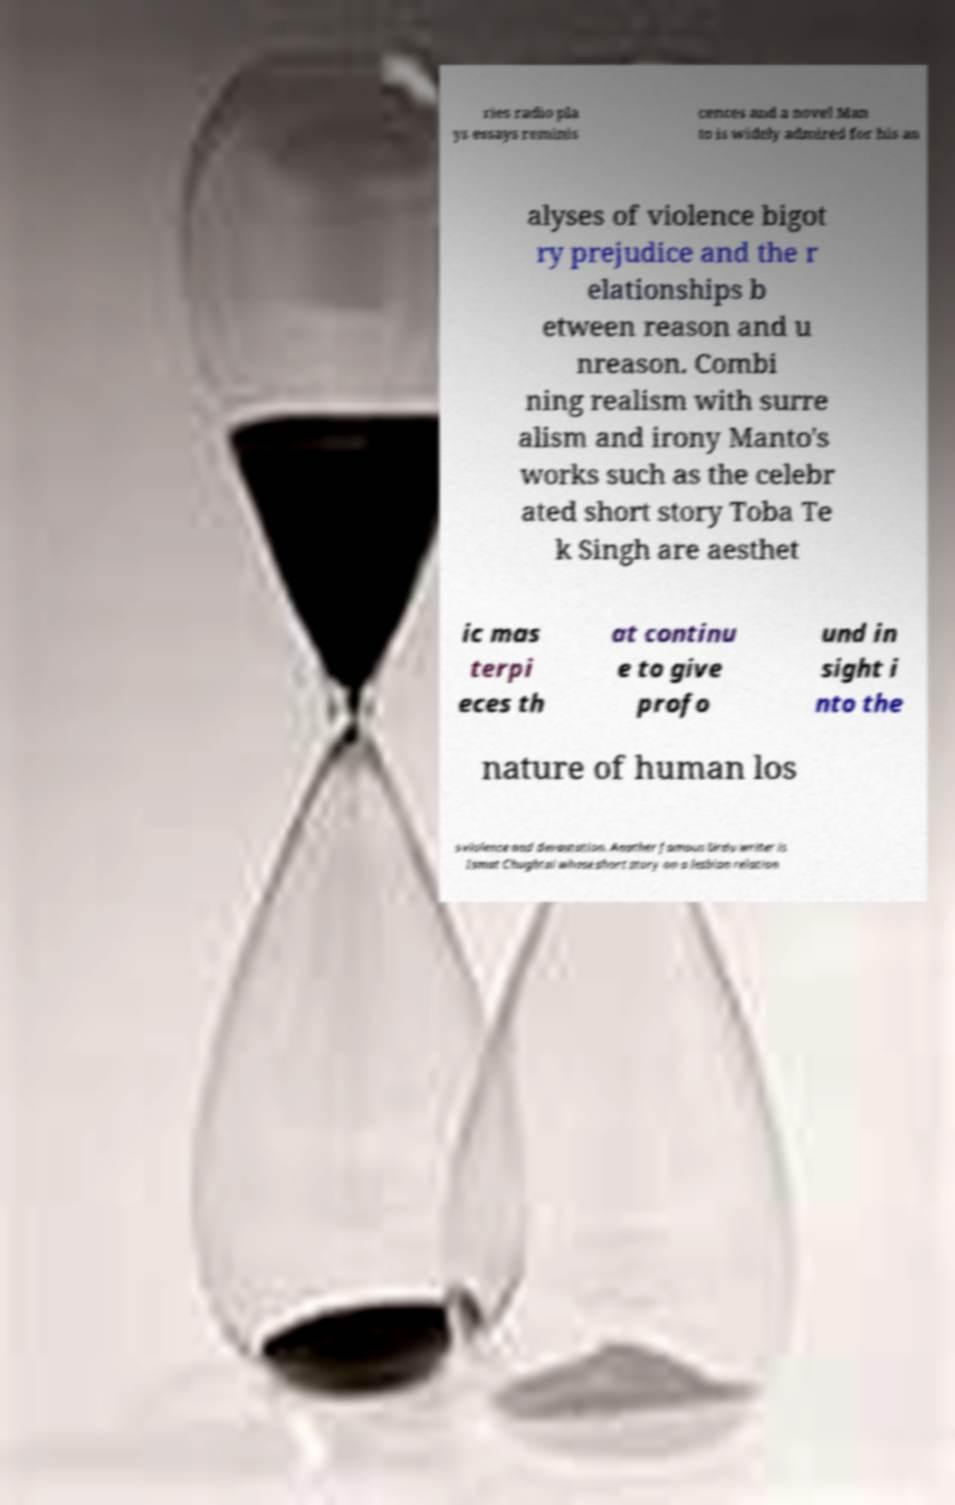Could you assist in decoding the text presented in this image and type it out clearly? ries radio pla ys essays reminis cences and a novel Man to is widely admired for his an alyses of violence bigot ry prejudice and the r elationships b etween reason and u nreason. Combi ning realism with surre alism and irony Manto's works such as the celebr ated short story Toba Te k Singh are aesthet ic mas terpi eces th at continu e to give profo und in sight i nto the nature of human los s violence and devastation. Another famous Urdu writer is Ismat Chughtai whose short story on a lesbian relation 